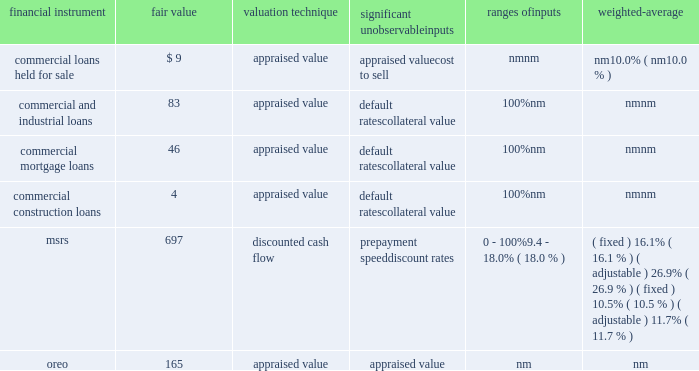Notes to consolidated financial statements 161 fifth third bancorp as of december 31 , 2012 ( $ in millions ) significant unobservable ranges of financial instrument fair value valuation technique inputs inputs weighted-average commercial loans held for sale $ 9 appraised value appraised value nm nm cost to sell nm 10.0% ( 10.0 % ) commercial and industrial loans 83 appraised value default rates 100% ( 100 % ) nm collateral value nm nm commercial mortgage loans 46 appraised value default rates 100% ( 100 % ) nm collateral value nm nm commercial construction loans 4 appraised value default rates 100% ( 100 % ) nm collateral value nm nm msrs 697 discounted cash flow prepayment speed 0 - 100% ( 100 % ) ( fixed ) 16.1% ( 16.1 % ) ( adjustable ) 26.9% ( 26.9 % ) discount rates 9.4 - 18.0% ( 18.0 % ) ( fixed ) 10.5% ( 10.5 % ) ( adjustable ) 11.7% ( 11.7 % ) .
Commercial loans held for sale during 2013 and 2012 , the bancorp transferred $ 5 million and $ 16 million , respectively , of commercial loans from the portfolio to loans held for sale that upon transfer were measured at fair value using significant unobservable inputs .
These loans had fair value adjustments in 2013 and 2012 totaling $ 4 million and $ 1 million , respectively , and were generally based on appraisals of the underlying collateral and were therefore , classified within level 3 of the valuation hierarchy .
Additionally , during 2013 and 2012 there were fair value adjustments on existing commercial loans held for sale of $ 3 million and $ 12 million , respectively .
The fair value adjustments were also based on appraisals of the underlying collateral and were therefore classified within level 3 of the valuation hierarchy .
An adverse change in the fair value of the underlying collateral would result in a decrease in the fair value measurement .
The accounting department determines the procedures for valuation of commercial hfs loans which may include a comparison to recently executed transactions of similar type loans .
A monthly review of the portfolio is performed for reasonableness .
Quarterly , appraisals approaching a year old are updated and the real estate valuation group , which reports to the chief risk and credit officer , in conjunction with the commercial line of business review the third party appraisals for reasonableness .
Additionally , the commercial line of business finance department , which reports to the bancorp chief financial officer , in conjunction with accounting review all loan appraisal values , carrying values and vintages .
Commercial loans held for investment during 2013 and 2012 , the bancorp recorded nonrecurring impairment adjustments to certain commercial and industrial , commercial mortgage and commercial construction loans held for investment .
Larger commercial loans included within aggregate borrower relationship balances exceeding $ 1 million that exhibit probable or observed credit weaknesses are subject to individual review for impairment .
The bancorp considers the current value of collateral , credit quality of any guarantees , the guarantor 2019s liquidity and willingness to cooperate , the loan structure and other factors when evaluating whether an individual loan is impaired .
When the loan is collateral dependent , the fair value of the loan is generally based on the fair value of the underlying collateral supporting the loan and therefore these loans were classified within level 3 of the valuation hierarchy .
In cases where the carrying value exceeds the fair value , an impairment loss is recognized .
An adverse change in the fair value of the underlying collateral would result in a decrease in the fair value measurement .
The fair values and recognized impairment losses are reflected in the previous table .
Commercial credit risk , which reports to the chief risk and credit officer , is responsible for preparing and reviewing the fair value estimates for commercial loans held for investment .
Mortgage interest rates increased during the year ended december 31 , 2013 and the bancorp recognized a recovery of temporary impairment on servicing rights .
The bancorp recognized temporary impairments in certain classes of the msr portfolio during the year ended december 31 , 2012 and the carrying value was adjusted to the fair value .
Msrs do not trade in an active , open market with readily observable prices .
While sales of msrs do occur , the precise terms and conditions typically are not readily available .
Accordingly , the bancorp estimates the fair value of msrs using internal discounted cash flow models with certain unobservable inputs , primarily prepayment speed assumptions , discount rates and weighted average lives , resulting in a classification within level 3 of the valuation hierarchy .
Refer to note 11 for further information on the assumptions used in the valuation of the bancorp 2019s msrs .
The secondary marketing department and treasury department are responsible for determining the valuation methodology for msrs .
Representatives from secondary marketing , treasury , accounting and risk management are responsible for reviewing key assumptions used in the internal discounted cash flow model .
Two external valuations of the msr portfolio are obtained from third parties that use valuation models in order to assess the reasonableness of the internal discounted cash flow model .
Additionally , the bancorp participates in peer surveys that provide additional confirmation of the reasonableness of key assumptions utilized in the msr valuation process and the resulting msr prices .
During 2013 and 2012 , the bancorp recorded nonrecurring adjustments to certain commercial and residential real estate properties classified as oreo and measured at the lower of carrying amount or fair value .
These nonrecurring losses are primarily due to declines in real estate values of the properties recorded in oreo .
For the years ended december 31 , 2013 and 2012 , these losses include $ 19 million and $ 17 million , respectively , recorded as charge-offs , on new oreo properties transferred from loans during the respective periods and $ 26 million and $ 57 million , respectively , recorded as negative fair value adjustments on oreo in other noninterest income subsequent to their transfer from loans .
As discussed in the following paragraphs , the fair value amounts are generally based on appraisals of the property values , resulting in a .
During 2013 , what were total losses in millions for charge-offs on new oreo properties and negative fair value adjustments on existing oreo properties? 
Computations: (19 + 26)
Answer: 45.0. 